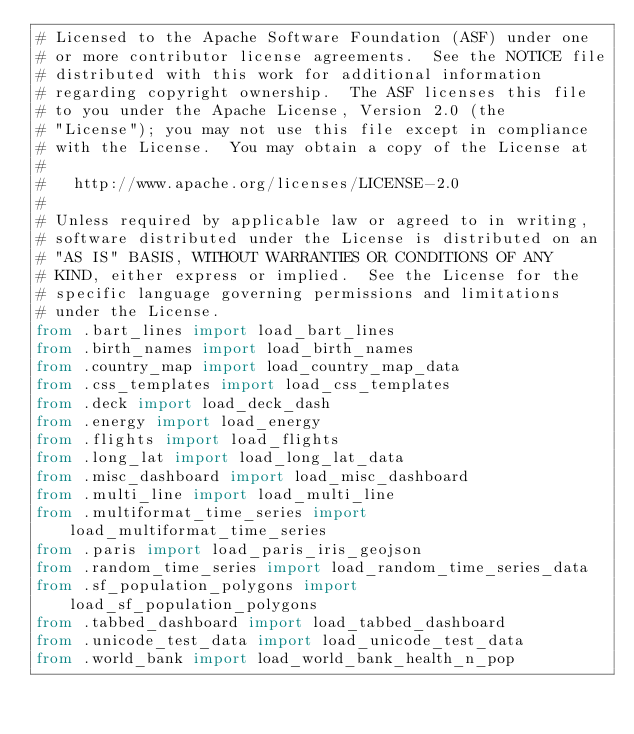Convert code to text. <code><loc_0><loc_0><loc_500><loc_500><_Python_># Licensed to the Apache Software Foundation (ASF) under one
# or more contributor license agreements.  See the NOTICE file
# distributed with this work for additional information
# regarding copyright ownership.  The ASF licenses this file
# to you under the Apache License, Version 2.0 (the
# "License"); you may not use this file except in compliance
# with the License.  You may obtain a copy of the License at
#
#   http://www.apache.org/licenses/LICENSE-2.0
#
# Unless required by applicable law or agreed to in writing,
# software distributed under the License is distributed on an
# "AS IS" BASIS, WITHOUT WARRANTIES OR CONDITIONS OF ANY
# KIND, either express or implied.  See the License for the
# specific language governing permissions and limitations
# under the License.
from .bart_lines import load_bart_lines
from .birth_names import load_birth_names
from .country_map import load_country_map_data
from .css_templates import load_css_templates
from .deck import load_deck_dash
from .energy import load_energy
from .flights import load_flights
from .long_lat import load_long_lat_data
from .misc_dashboard import load_misc_dashboard
from .multi_line import load_multi_line
from .multiformat_time_series import load_multiformat_time_series
from .paris import load_paris_iris_geojson
from .random_time_series import load_random_time_series_data
from .sf_population_polygons import load_sf_population_polygons
from .tabbed_dashboard import load_tabbed_dashboard
from .unicode_test_data import load_unicode_test_data
from .world_bank import load_world_bank_health_n_pop
</code> 